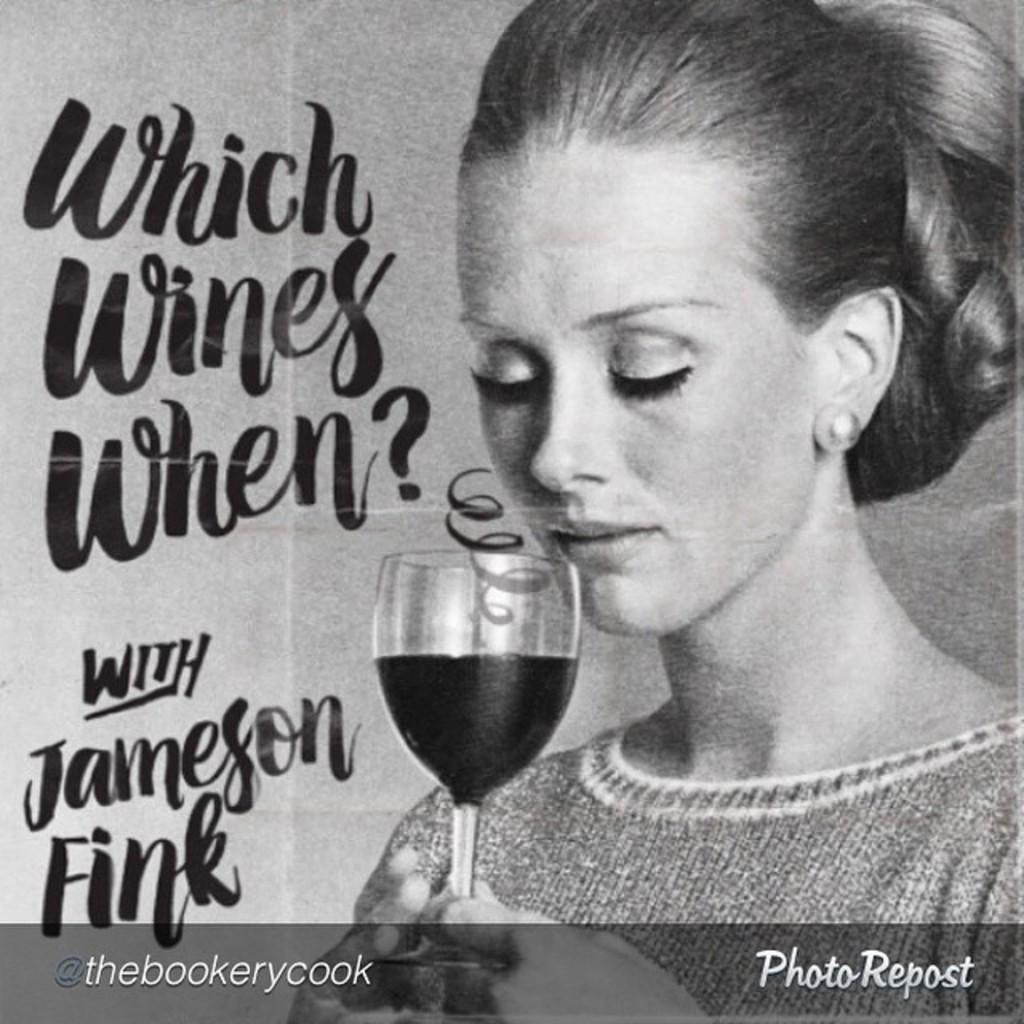What type of image is being described? The image is a poster. Who or what is depicted on the poster? There is a woman on the poster. What is the woman holding in the image? The woman is holding a glass with a drink in it. Is there any text on the poster? Yes, there is text on the poster. Can you tell me how many flowers are in the garden shown on the poster? There is no garden depicted on the poster, so it is not possible to determine the number of flowers. 